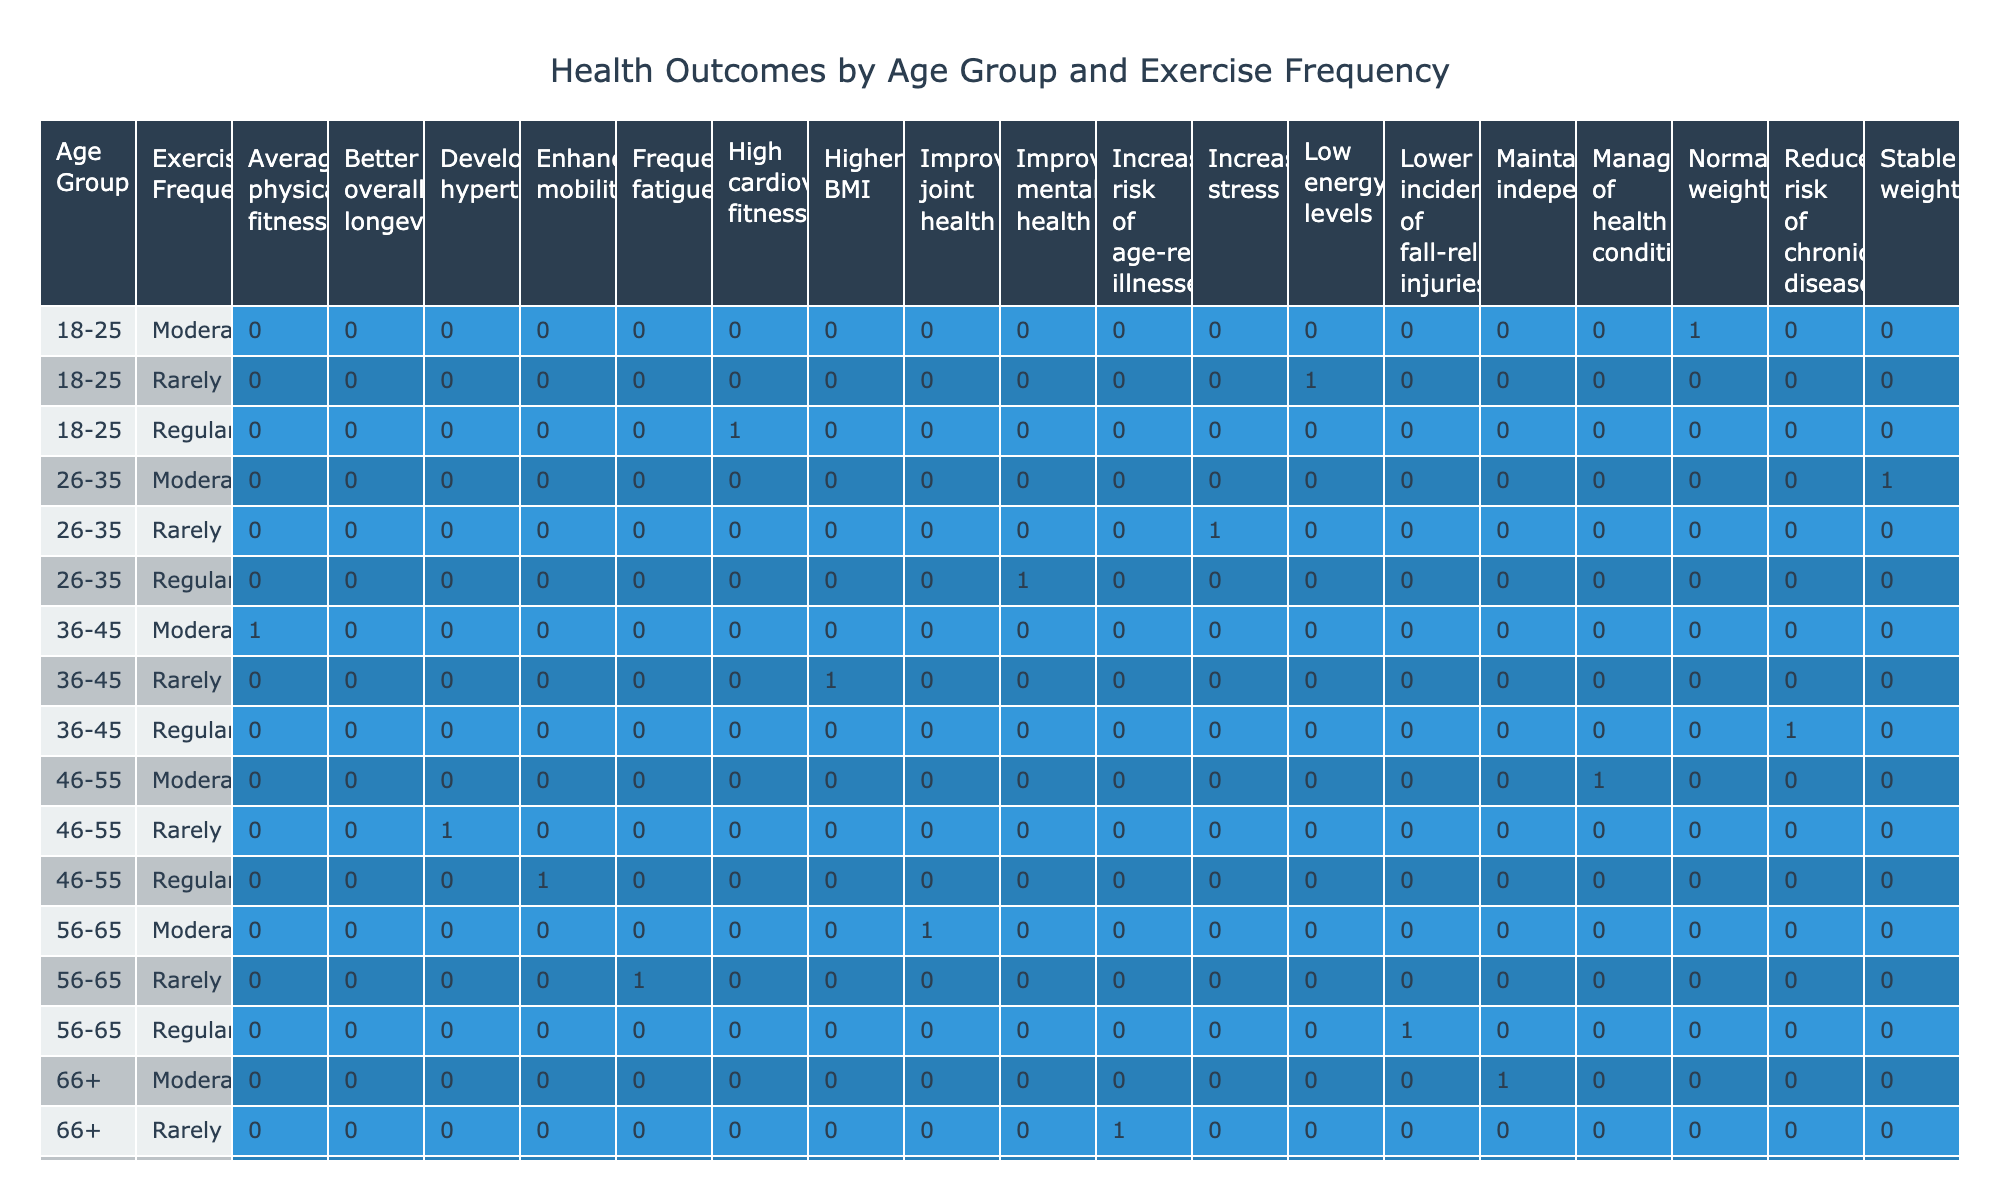What health outcome is associated with regular exercise for individuals aged 18-25? The table indicates that for the age group 18-25, the health outcome associated with regular exercise is "High cardiovascular fitness." This can be directly retrieved from the corresponding row under the "Health Outcomes" column next to "Regular" and "18-25."
Answer: High cardiovascular fitness How many age groups are represented for individuals who exercise regularly? By examining the table, we can see the age groups listed alongside their corresponding health outcomes for regular exercise. There are six distinct age groups (18-25, 26-35, 36-45, 46-55, 56-65, and 66+) shown in the rows of the table.
Answer: Six age groups Is the health outcome for rarely exercising in the 46-55 age group developing hypertension? The table provides a specific entry for the 46-55 age group under "Rarely" exercising, which indicates the health outcome as "Developing hypertension." Therefore, this statement is true based on the data presented.
Answer: Yes What is the total number of distinct health outcomes listed for all age groups? The health outcomes are displayed in the table according to various combinations of age groups and exercise frequencies. Listing them out gives us a total of 12 unique health outcomes: High cardiovascular fitness, Normal weight, Low energy levels, Improved mental health, Stable weight, Increased stress, Reduced risk of chronic diseases, Average physical fitness, Higher BMI, Enhanced mobility, Management of health conditions, Frequent fatigue, Lower incidence of fall-related injuries, Improved joint health, Better overall longevity, Maintained independence, Increased risk of age-related illnesses. Counting these gives us 12.
Answer: Twelve For individuals aged 36-45, what is the average health outcome between regular and moderate exercise? In the 36-45 age group, the health outcomes for regular exercise is "Reduced risk of chronic diseases," and for moderate exercise, it is "Average physical fitness." To interpret this, we assign numeric values to these outcomes, but since they are qualitative, averaging their effects isn't straightforward. Instead, summarizing them suggests that both outcomes indicate overall better health status compared to those who rarely exercise. Thus, the emphasis should remain on qualitative interpretation rather than numerical.
Answer: Reduced risk of chronic diseases and Average physical fitness (qualitative interpretation) Do moderate exercisers in the 56-65 age group show any improved health outcomes? According to the table, the health outcome for moderate exercisers in the 56-65 age group is "Improved joint health." This indicates that moderate exercise relates to a positive health outcome for this demographic. Therefore, the answer is affirmative.
Answer: Yes 